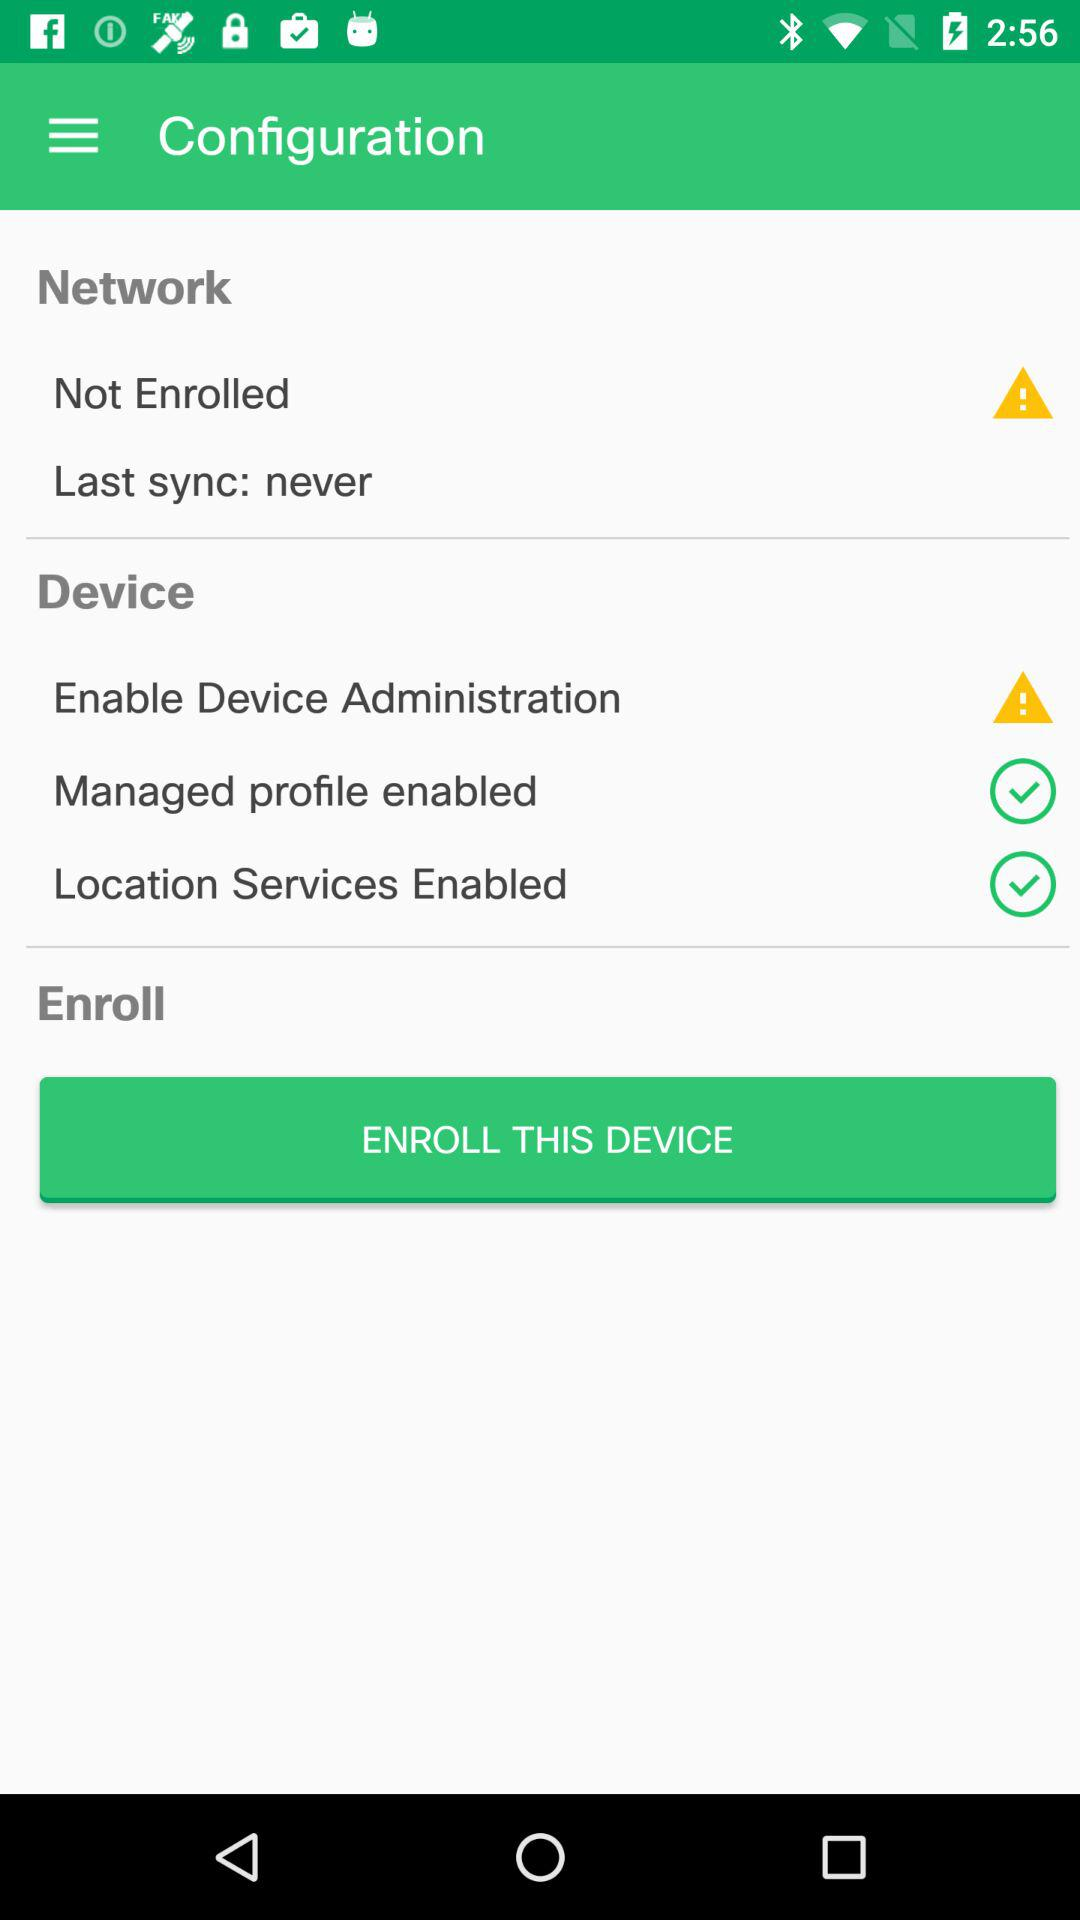How many more items are in the Device section than in the Network section?
Answer the question using a single word or phrase. 2 